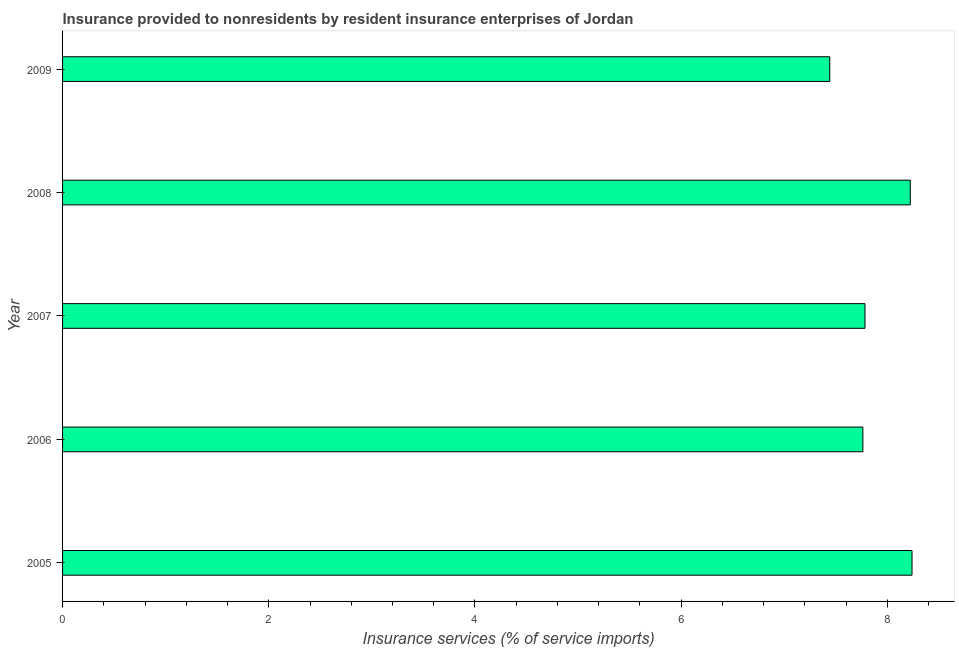Does the graph contain any zero values?
Your response must be concise. No. Does the graph contain grids?
Your answer should be very brief. No. What is the title of the graph?
Provide a short and direct response. Insurance provided to nonresidents by resident insurance enterprises of Jordan. What is the label or title of the X-axis?
Give a very brief answer. Insurance services (% of service imports). What is the insurance and financial services in 2005?
Provide a short and direct response. 8.24. Across all years, what is the maximum insurance and financial services?
Make the answer very short. 8.24. Across all years, what is the minimum insurance and financial services?
Make the answer very short. 7.44. In which year was the insurance and financial services minimum?
Your response must be concise. 2009. What is the sum of the insurance and financial services?
Offer a terse response. 39.45. What is the difference between the insurance and financial services in 2005 and 2006?
Keep it short and to the point. 0.48. What is the average insurance and financial services per year?
Give a very brief answer. 7.89. What is the median insurance and financial services?
Keep it short and to the point. 7.78. In how many years, is the insurance and financial services greater than 3.6 %?
Your answer should be compact. 5. Do a majority of the years between 2008 and 2009 (inclusive) have insurance and financial services greater than 6.8 %?
Provide a short and direct response. Yes. What is the ratio of the insurance and financial services in 2008 to that in 2009?
Your answer should be very brief. 1.1. Is the difference between the insurance and financial services in 2006 and 2009 greater than the difference between any two years?
Provide a short and direct response. No. What is the difference between the highest and the second highest insurance and financial services?
Your answer should be compact. 0.02. Is the sum of the insurance and financial services in 2007 and 2009 greater than the maximum insurance and financial services across all years?
Give a very brief answer. Yes. What is the difference between the highest and the lowest insurance and financial services?
Make the answer very short. 0.8. In how many years, is the insurance and financial services greater than the average insurance and financial services taken over all years?
Keep it short and to the point. 2. How many bars are there?
Keep it short and to the point. 5. What is the difference between two consecutive major ticks on the X-axis?
Keep it short and to the point. 2. Are the values on the major ticks of X-axis written in scientific E-notation?
Keep it short and to the point. No. What is the Insurance services (% of service imports) of 2005?
Provide a short and direct response. 8.24. What is the Insurance services (% of service imports) in 2006?
Give a very brief answer. 7.76. What is the Insurance services (% of service imports) in 2007?
Provide a short and direct response. 7.78. What is the Insurance services (% of service imports) in 2008?
Offer a very short reply. 8.22. What is the Insurance services (% of service imports) of 2009?
Offer a terse response. 7.44. What is the difference between the Insurance services (% of service imports) in 2005 and 2006?
Offer a terse response. 0.48. What is the difference between the Insurance services (% of service imports) in 2005 and 2007?
Provide a succinct answer. 0.46. What is the difference between the Insurance services (% of service imports) in 2005 and 2008?
Ensure brevity in your answer.  0.02. What is the difference between the Insurance services (% of service imports) in 2005 and 2009?
Give a very brief answer. 0.8. What is the difference between the Insurance services (% of service imports) in 2006 and 2007?
Make the answer very short. -0.02. What is the difference between the Insurance services (% of service imports) in 2006 and 2008?
Keep it short and to the point. -0.46. What is the difference between the Insurance services (% of service imports) in 2006 and 2009?
Your answer should be very brief. 0.32. What is the difference between the Insurance services (% of service imports) in 2007 and 2008?
Provide a short and direct response. -0.44. What is the difference between the Insurance services (% of service imports) in 2007 and 2009?
Offer a terse response. 0.34. What is the difference between the Insurance services (% of service imports) in 2008 and 2009?
Provide a short and direct response. 0.78. What is the ratio of the Insurance services (% of service imports) in 2005 to that in 2006?
Keep it short and to the point. 1.06. What is the ratio of the Insurance services (% of service imports) in 2005 to that in 2007?
Give a very brief answer. 1.06. What is the ratio of the Insurance services (% of service imports) in 2005 to that in 2008?
Make the answer very short. 1. What is the ratio of the Insurance services (% of service imports) in 2005 to that in 2009?
Your answer should be very brief. 1.11. What is the ratio of the Insurance services (% of service imports) in 2006 to that in 2008?
Your answer should be very brief. 0.94. What is the ratio of the Insurance services (% of service imports) in 2006 to that in 2009?
Offer a very short reply. 1.04. What is the ratio of the Insurance services (% of service imports) in 2007 to that in 2008?
Make the answer very short. 0.95. What is the ratio of the Insurance services (% of service imports) in 2007 to that in 2009?
Ensure brevity in your answer.  1.05. What is the ratio of the Insurance services (% of service imports) in 2008 to that in 2009?
Keep it short and to the point. 1.1. 